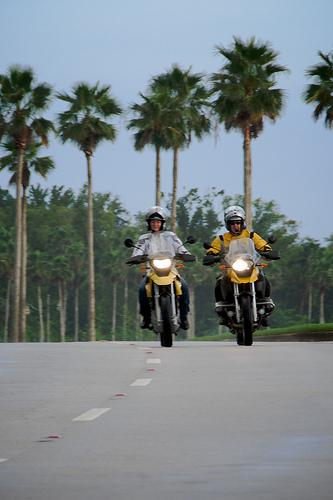Question: how many people are in the picture?
Choices:
A. One.
B. Three.
C. Four.
D. Two.
Answer with the letter. Answer: D Question: what type of vehicle is in the picture?
Choices:
A. Car.
B. Bus.
C. Motorcycle.
D. Train.
Answer with the letter. Answer: C Question: where was this picture taken?
Choices:
A. On the road.
B. By the house.
C. At the beach.
D. Near the school.
Answer with the letter. Answer: A Question: how many clouds are in the sky?
Choices:
A. One.
B. Two.
C. Three.
D. None.
Answer with the letter. Answer: D Question: how many palm trees are in the picture?
Choices:
A. Seven.
B. Five.
C. Three.
D. One.
Answer with the letter. Answer: A Question: what are the riders wearing on their heads?
Choices:
A. Caps.
B. Scarves.
C. Helmets.
D. Sunglasses.
Answer with the letter. Answer: C 